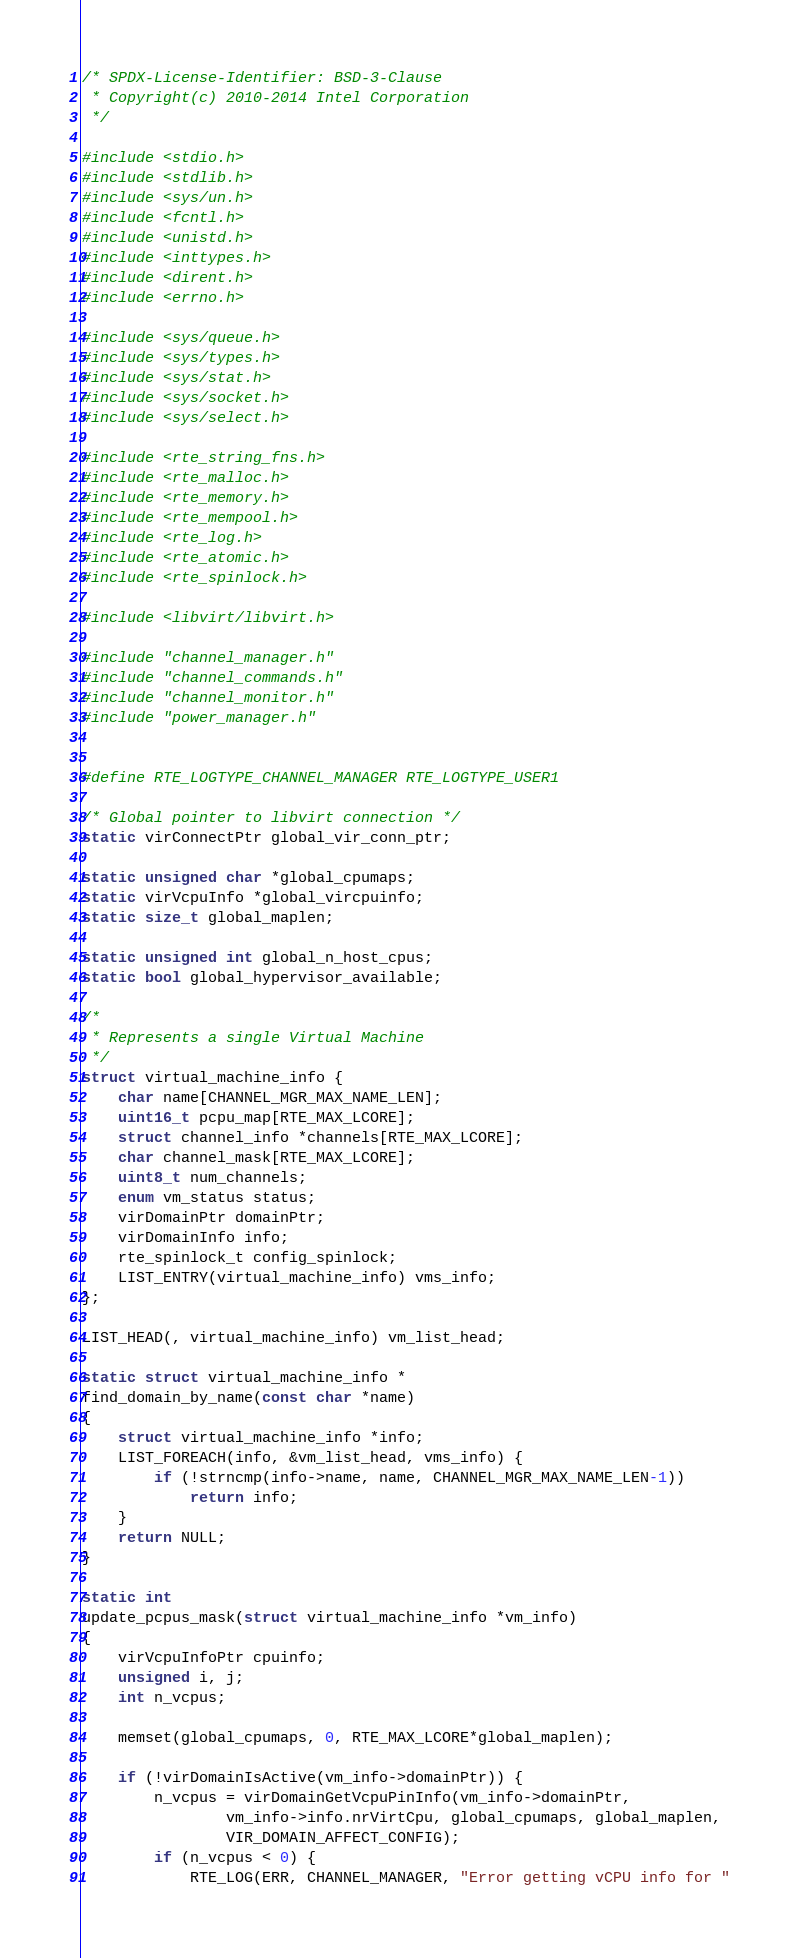Convert code to text. <code><loc_0><loc_0><loc_500><loc_500><_C_>/* SPDX-License-Identifier: BSD-3-Clause
 * Copyright(c) 2010-2014 Intel Corporation
 */

#include <stdio.h>
#include <stdlib.h>
#include <sys/un.h>
#include <fcntl.h>
#include <unistd.h>
#include <inttypes.h>
#include <dirent.h>
#include <errno.h>

#include <sys/queue.h>
#include <sys/types.h>
#include <sys/stat.h>
#include <sys/socket.h>
#include <sys/select.h>

#include <rte_string_fns.h>
#include <rte_malloc.h>
#include <rte_memory.h>
#include <rte_mempool.h>
#include <rte_log.h>
#include <rte_atomic.h>
#include <rte_spinlock.h>

#include <libvirt/libvirt.h>

#include "channel_manager.h"
#include "channel_commands.h"
#include "channel_monitor.h"
#include "power_manager.h"


#define RTE_LOGTYPE_CHANNEL_MANAGER RTE_LOGTYPE_USER1

/* Global pointer to libvirt connection */
static virConnectPtr global_vir_conn_ptr;

static unsigned char *global_cpumaps;
static virVcpuInfo *global_vircpuinfo;
static size_t global_maplen;

static unsigned int global_n_host_cpus;
static bool global_hypervisor_available;

/*
 * Represents a single Virtual Machine
 */
struct virtual_machine_info {
	char name[CHANNEL_MGR_MAX_NAME_LEN];
	uint16_t pcpu_map[RTE_MAX_LCORE];
	struct channel_info *channels[RTE_MAX_LCORE];
	char channel_mask[RTE_MAX_LCORE];
	uint8_t num_channels;
	enum vm_status status;
	virDomainPtr domainPtr;
	virDomainInfo info;
	rte_spinlock_t config_spinlock;
	LIST_ENTRY(virtual_machine_info) vms_info;
};

LIST_HEAD(, virtual_machine_info) vm_list_head;

static struct virtual_machine_info *
find_domain_by_name(const char *name)
{
	struct virtual_machine_info *info;
	LIST_FOREACH(info, &vm_list_head, vms_info) {
		if (!strncmp(info->name, name, CHANNEL_MGR_MAX_NAME_LEN-1))
			return info;
	}
	return NULL;
}

static int
update_pcpus_mask(struct virtual_machine_info *vm_info)
{
	virVcpuInfoPtr cpuinfo;
	unsigned i, j;
	int n_vcpus;

	memset(global_cpumaps, 0, RTE_MAX_LCORE*global_maplen);

	if (!virDomainIsActive(vm_info->domainPtr)) {
		n_vcpus = virDomainGetVcpuPinInfo(vm_info->domainPtr,
				vm_info->info.nrVirtCpu, global_cpumaps, global_maplen,
				VIR_DOMAIN_AFFECT_CONFIG);
		if (n_vcpus < 0) {
			RTE_LOG(ERR, CHANNEL_MANAGER, "Error getting vCPU info for "</code> 